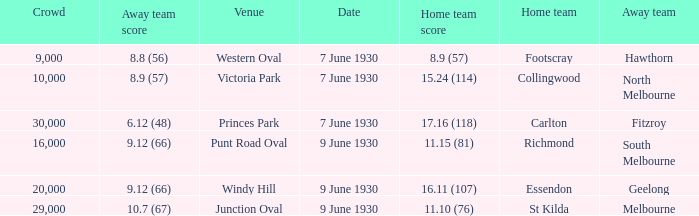What is the smallest crowd to see the away team score 10.7 (67)? 29000.0. 